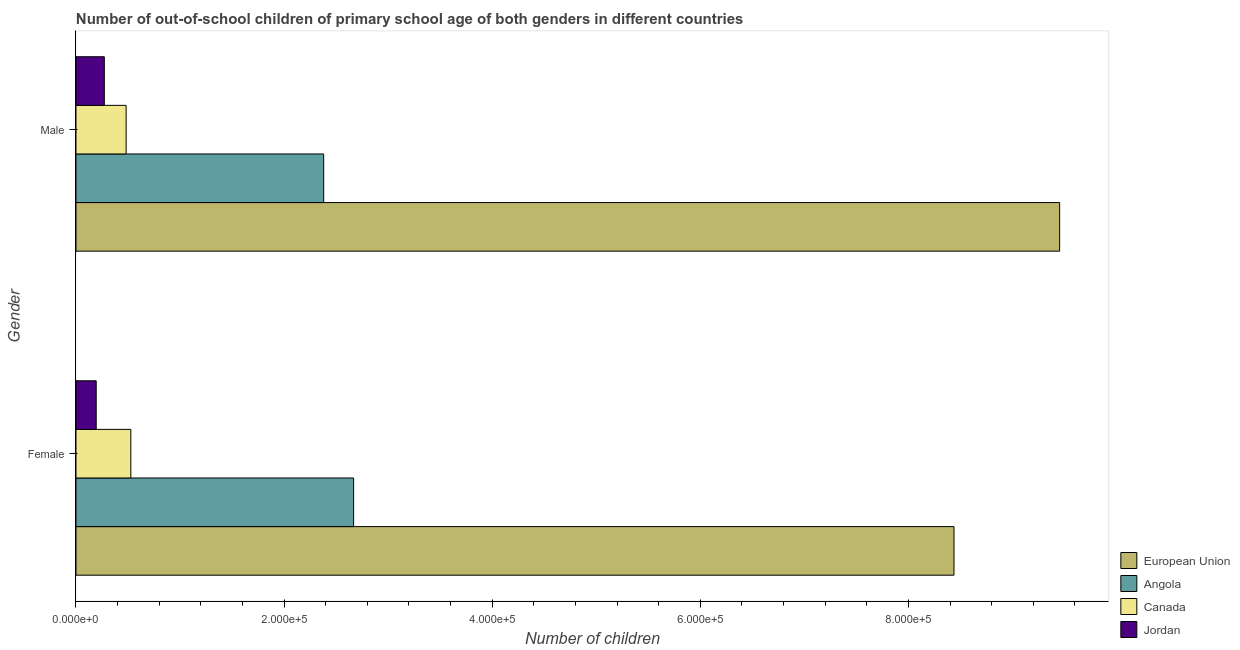How many groups of bars are there?
Your response must be concise. 2. How many bars are there on the 1st tick from the bottom?
Offer a terse response. 4. What is the number of female out-of-school students in Canada?
Make the answer very short. 5.27e+04. Across all countries, what is the maximum number of female out-of-school students?
Your answer should be very brief. 8.44e+05. Across all countries, what is the minimum number of male out-of-school students?
Ensure brevity in your answer.  2.72e+04. In which country was the number of male out-of-school students minimum?
Ensure brevity in your answer.  Jordan. What is the total number of female out-of-school students in the graph?
Offer a terse response. 1.18e+06. What is the difference between the number of female out-of-school students in Canada and that in Jordan?
Your answer should be very brief. 3.33e+04. What is the difference between the number of female out-of-school students in Angola and the number of male out-of-school students in Jordan?
Give a very brief answer. 2.40e+05. What is the average number of male out-of-school students per country?
Offer a very short reply. 3.15e+05. What is the difference between the number of female out-of-school students and number of male out-of-school students in Canada?
Your answer should be very brief. 4513. What is the ratio of the number of female out-of-school students in Angola to that in Canada?
Your answer should be very brief. 5.06. In how many countries, is the number of female out-of-school students greater than the average number of female out-of-school students taken over all countries?
Offer a very short reply. 1. What does the 2nd bar from the bottom in Female represents?
Offer a terse response. Angola. How many countries are there in the graph?
Offer a very short reply. 4. Does the graph contain any zero values?
Make the answer very short. No. Where does the legend appear in the graph?
Provide a succinct answer. Bottom right. What is the title of the graph?
Give a very brief answer. Number of out-of-school children of primary school age of both genders in different countries. What is the label or title of the X-axis?
Offer a terse response. Number of children. What is the Number of children in European Union in Female?
Your response must be concise. 8.44e+05. What is the Number of children in Angola in Female?
Offer a very short reply. 2.67e+05. What is the Number of children of Canada in Female?
Provide a succinct answer. 5.27e+04. What is the Number of children of Jordan in Female?
Provide a succinct answer. 1.94e+04. What is the Number of children of European Union in Male?
Your response must be concise. 9.45e+05. What is the Number of children in Angola in Male?
Your answer should be compact. 2.38e+05. What is the Number of children of Canada in Male?
Provide a short and direct response. 4.82e+04. What is the Number of children of Jordan in Male?
Ensure brevity in your answer.  2.72e+04. Across all Gender, what is the maximum Number of children of European Union?
Make the answer very short. 9.45e+05. Across all Gender, what is the maximum Number of children of Angola?
Provide a short and direct response. 2.67e+05. Across all Gender, what is the maximum Number of children of Canada?
Offer a very short reply. 5.27e+04. Across all Gender, what is the maximum Number of children in Jordan?
Keep it short and to the point. 2.72e+04. Across all Gender, what is the minimum Number of children in European Union?
Ensure brevity in your answer.  8.44e+05. Across all Gender, what is the minimum Number of children in Angola?
Provide a succinct answer. 2.38e+05. Across all Gender, what is the minimum Number of children of Canada?
Ensure brevity in your answer.  4.82e+04. Across all Gender, what is the minimum Number of children in Jordan?
Ensure brevity in your answer.  1.94e+04. What is the total Number of children in European Union in the graph?
Give a very brief answer. 1.79e+06. What is the total Number of children of Angola in the graph?
Keep it short and to the point. 5.05e+05. What is the total Number of children of Canada in the graph?
Ensure brevity in your answer.  1.01e+05. What is the total Number of children of Jordan in the graph?
Provide a succinct answer. 4.66e+04. What is the difference between the Number of children of European Union in Female and that in Male?
Make the answer very short. -1.02e+05. What is the difference between the Number of children of Angola in Female and that in Male?
Provide a succinct answer. 2.88e+04. What is the difference between the Number of children in Canada in Female and that in Male?
Provide a short and direct response. 4513. What is the difference between the Number of children in Jordan in Female and that in Male?
Offer a terse response. -7810. What is the difference between the Number of children in European Union in Female and the Number of children in Angola in Male?
Give a very brief answer. 6.06e+05. What is the difference between the Number of children in European Union in Female and the Number of children in Canada in Male?
Ensure brevity in your answer.  7.96e+05. What is the difference between the Number of children of European Union in Female and the Number of children of Jordan in Male?
Your answer should be compact. 8.17e+05. What is the difference between the Number of children in Angola in Female and the Number of children in Canada in Male?
Make the answer very short. 2.19e+05. What is the difference between the Number of children in Angola in Female and the Number of children in Jordan in Male?
Give a very brief answer. 2.40e+05. What is the difference between the Number of children of Canada in Female and the Number of children of Jordan in Male?
Your answer should be compact. 2.55e+04. What is the average Number of children in European Union per Gender?
Keep it short and to the point. 8.95e+05. What is the average Number of children of Angola per Gender?
Offer a very short reply. 2.52e+05. What is the average Number of children of Canada per Gender?
Provide a succinct answer. 5.05e+04. What is the average Number of children of Jordan per Gender?
Make the answer very short. 2.33e+04. What is the difference between the Number of children of European Union and Number of children of Angola in Female?
Make the answer very short. 5.77e+05. What is the difference between the Number of children of European Union and Number of children of Canada in Female?
Ensure brevity in your answer.  7.91e+05. What is the difference between the Number of children of European Union and Number of children of Jordan in Female?
Offer a terse response. 8.24e+05. What is the difference between the Number of children of Angola and Number of children of Canada in Female?
Provide a succinct answer. 2.14e+05. What is the difference between the Number of children in Angola and Number of children in Jordan in Female?
Offer a terse response. 2.47e+05. What is the difference between the Number of children in Canada and Number of children in Jordan in Female?
Your answer should be very brief. 3.33e+04. What is the difference between the Number of children of European Union and Number of children of Angola in Male?
Make the answer very short. 7.07e+05. What is the difference between the Number of children of European Union and Number of children of Canada in Male?
Ensure brevity in your answer.  8.97e+05. What is the difference between the Number of children in European Union and Number of children in Jordan in Male?
Make the answer very short. 9.18e+05. What is the difference between the Number of children of Angola and Number of children of Canada in Male?
Offer a terse response. 1.90e+05. What is the difference between the Number of children of Angola and Number of children of Jordan in Male?
Ensure brevity in your answer.  2.11e+05. What is the difference between the Number of children in Canada and Number of children in Jordan in Male?
Provide a short and direct response. 2.10e+04. What is the ratio of the Number of children in European Union in Female to that in Male?
Ensure brevity in your answer.  0.89. What is the ratio of the Number of children in Angola in Female to that in Male?
Provide a succinct answer. 1.12. What is the ratio of the Number of children of Canada in Female to that in Male?
Your answer should be compact. 1.09. What is the ratio of the Number of children in Jordan in Female to that in Male?
Keep it short and to the point. 0.71. What is the difference between the highest and the second highest Number of children in European Union?
Provide a succinct answer. 1.02e+05. What is the difference between the highest and the second highest Number of children in Angola?
Provide a succinct answer. 2.88e+04. What is the difference between the highest and the second highest Number of children in Canada?
Provide a succinct answer. 4513. What is the difference between the highest and the second highest Number of children of Jordan?
Provide a succinct answer. 7810. What is the difference between the highest and the lowest Number of children in European Union?
Your response must be concise. 1.02e+05. What is the difference between the highest and the lowest Number of children of Angola?
Offer a terse response. 2.88e+04. What is the difference between the highest and the lowest Number of children of Canada?
Give a very brief answer. 4513. What is the difference between the highest and the lowest Number of children in Jordan?
Offer a very short reply. 7810. 